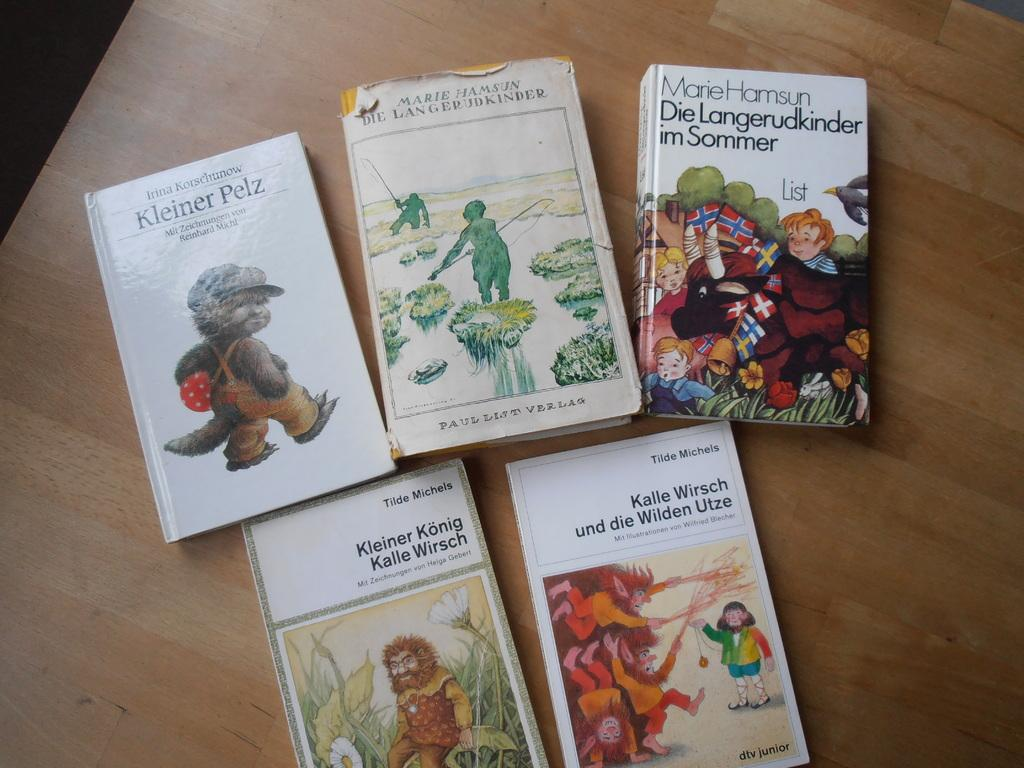<image>
Render a clear and concise summary of the photo. Five books sitting on a table, one with the title Kleiner Konig Kalle Wirsch. 